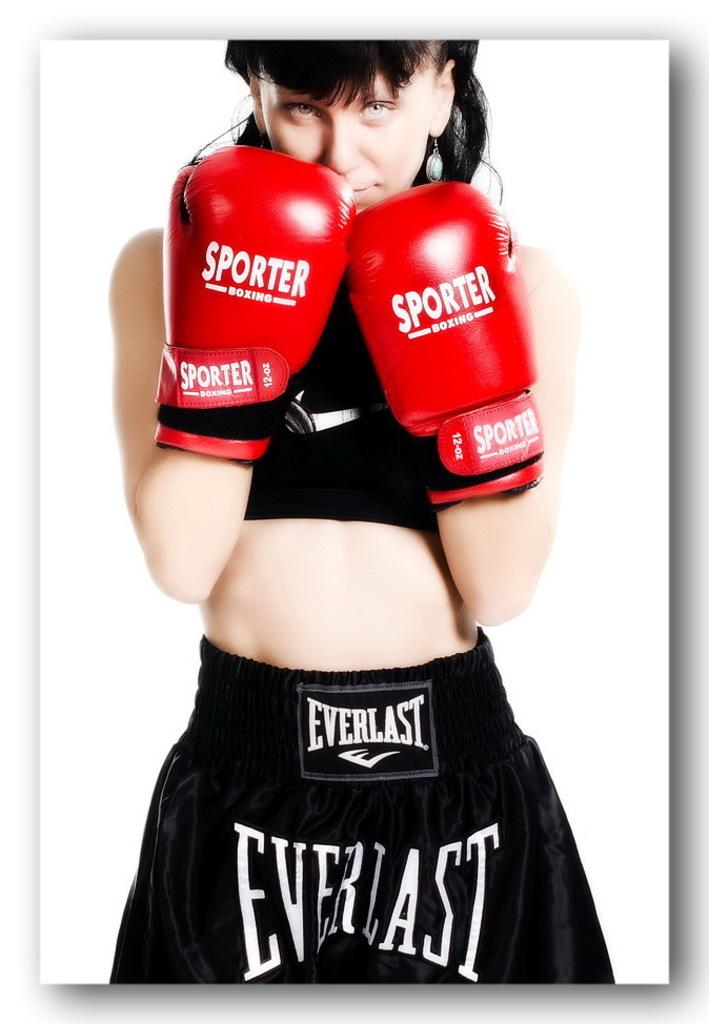<image>
Provide a brief description of the given image. Female boxer wearing Sporter brand boxing gloves and Everlast shorts. 